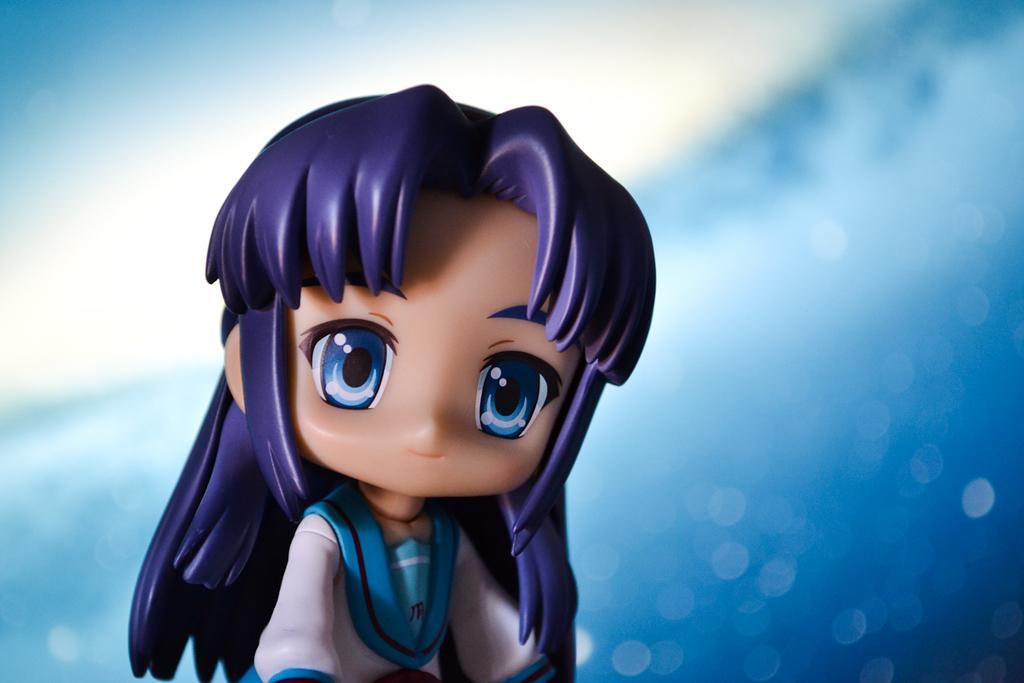Please provide a concise description of this image. Here we can see a toy. Background it is white and blue. 